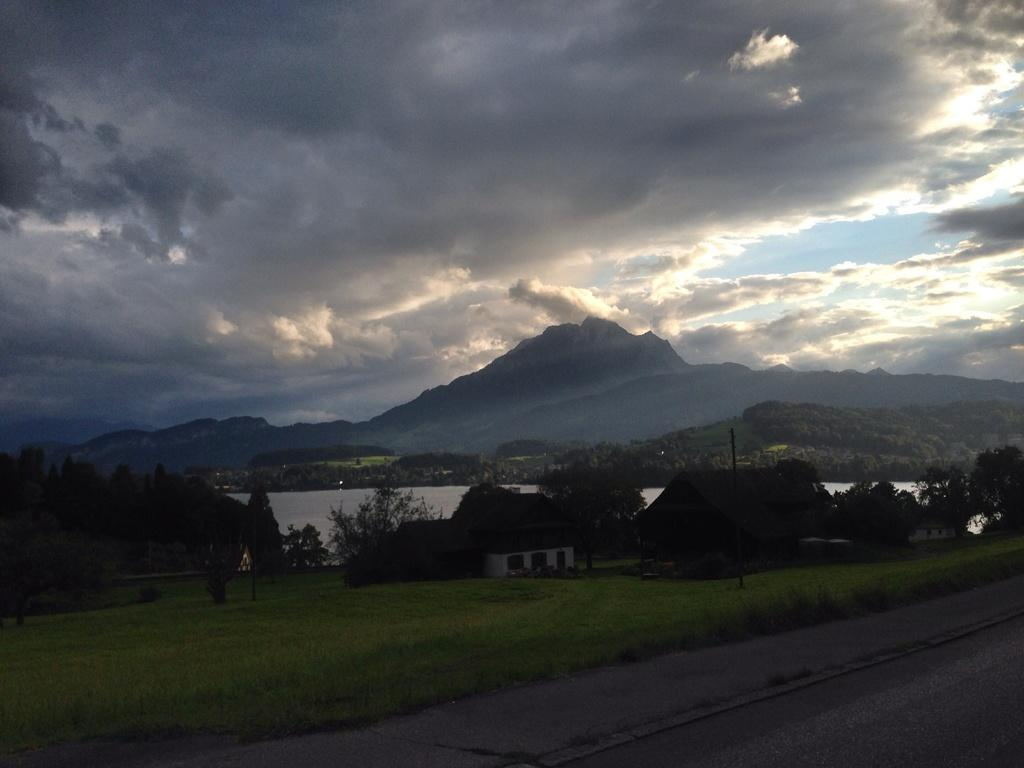Where was the image taken? The image was clicked outside. What can be seen in the middle of the image? There is water, trees, and mountains in the middle of the image. What is visible at the top of the image? The sky is visible at the top of the image. What type of ink is used to draw the mountains in the image? There is no ink present in the image, as it is a photograph of real mountains. Is there any powder visible in the image? There is no powder visible in the image; it features water, trees, mountains, and the sky. 